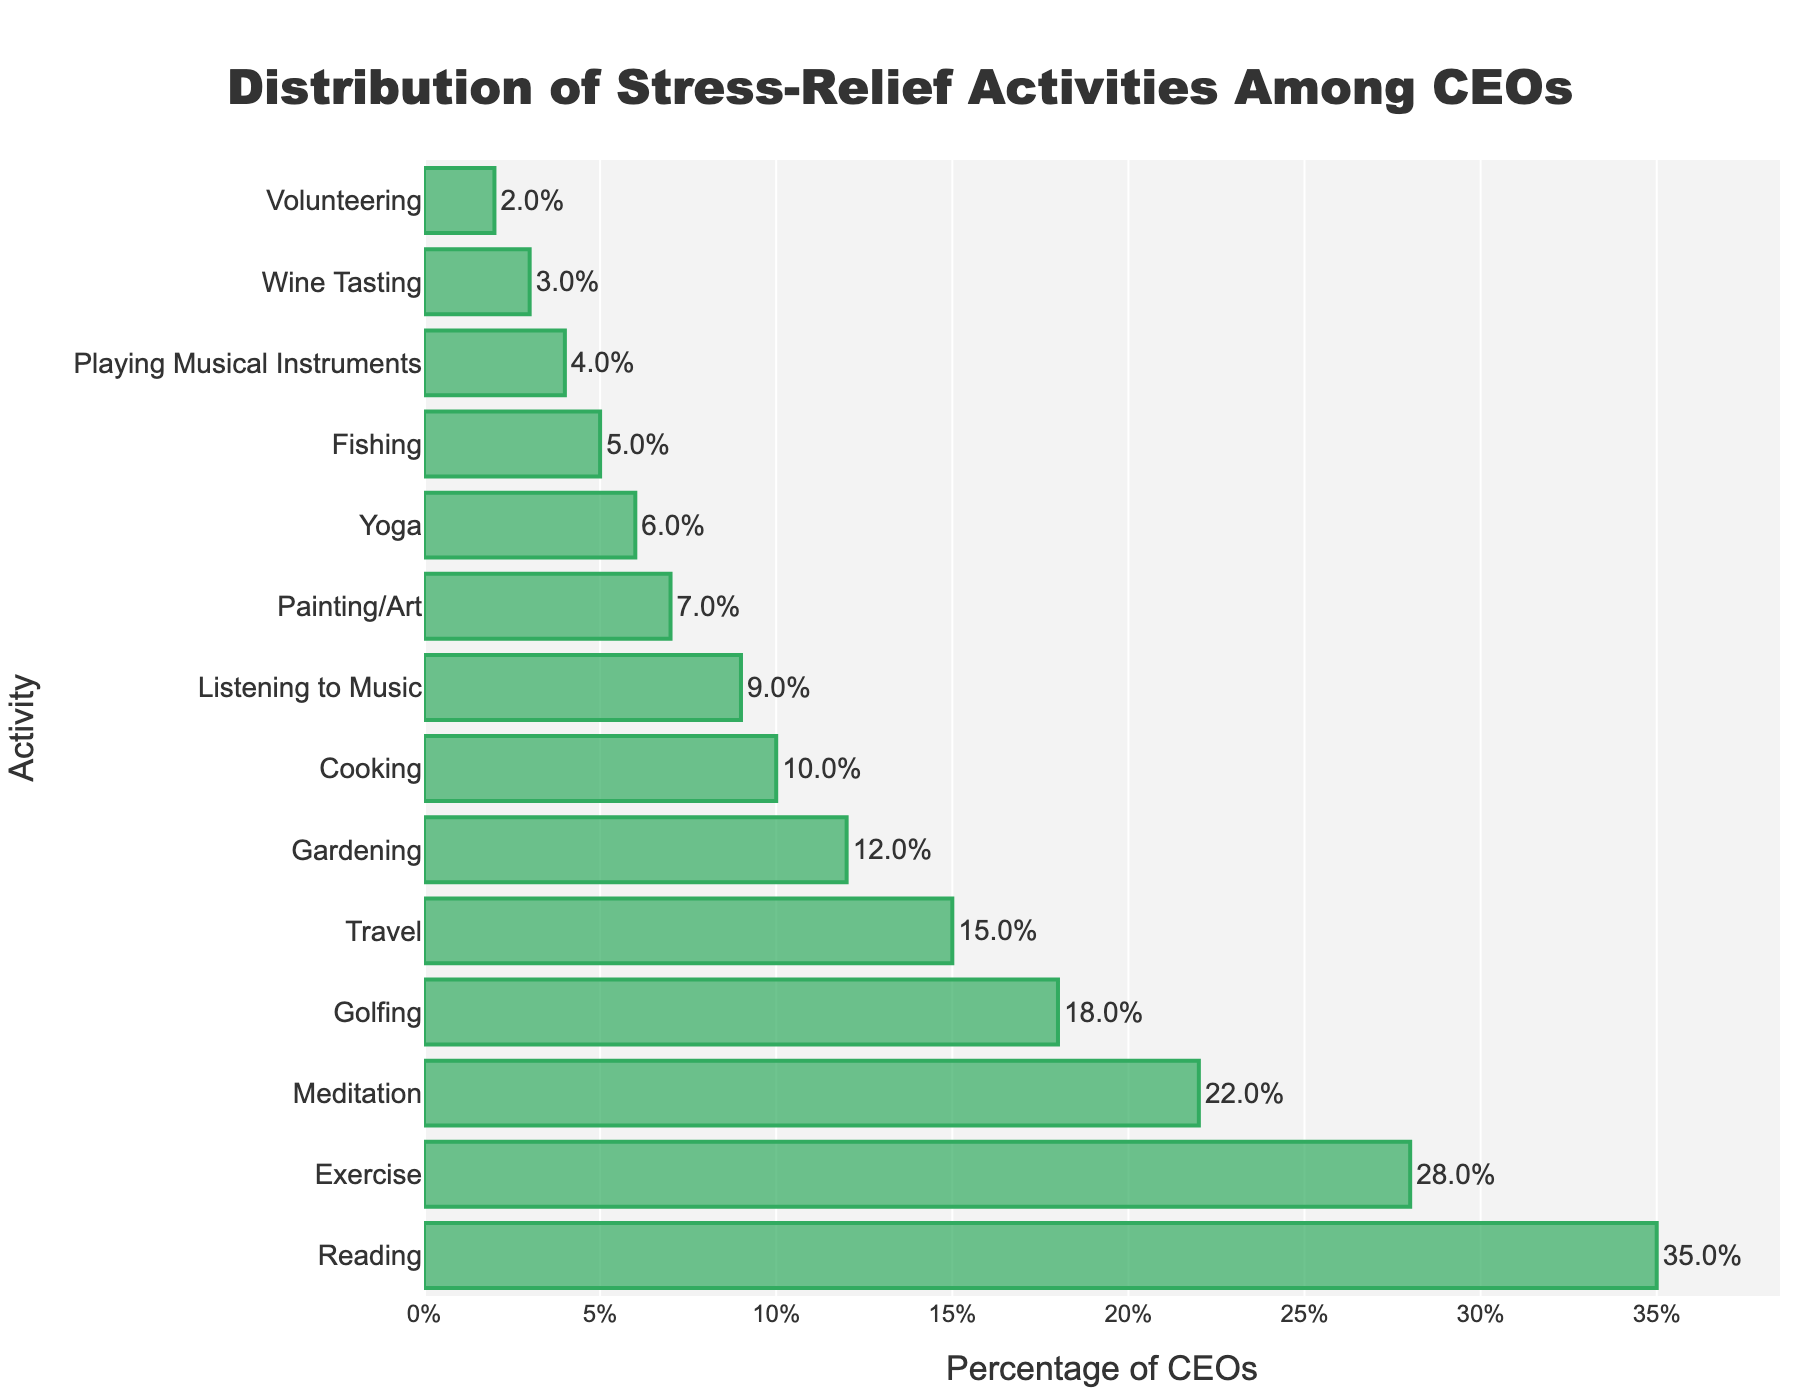Which stress-relief activity is the most popular among CEOs? The figure shows that the bar for "Reading" is the longest, indicating it has the highest percentage among the listed activities.
Answer: Reading How much more popular is exercise compared to gardening? From the figure, "Exercise" is at 28% and "Gardening" at 12%. Subtracting the percentage for gardening from exercise: 28% - 12% = 16%.
Answer: 16% What are the top three stress-relief activities among CEOs? The top three activities can be identified by looking at the three longest bars in the chart, which are "Reading" (35%), "Exercise" (28%), and "Meditation" (22%).
Answer: Reading, Exercise, Meditation Which stress-relief activity is just below golfing in popularity? By examining the chart, the activity listed immediately below "Golfing" (18%) is "Travel" at 15%.
Answer: Travel How many stress-relief activities have a percentage greater than 20%? By counting the bars with percentages greater than 20%, we find "Reading" (35%), "Exercise" (28%), and "Meditation" (22%), totaling to three activities.
Answer: 3 Is cooking more or less popular than listening to music? By comparing the lengths of the bars, "Cooking" (10%) is more popular than "Listening to Music" (9%).
Answer: More What is the total percentage of CEOs who engage in yoga and fishing? Summing up the percentages for "Yoga" (6%) and "Fishing" (5%) results in 6% + 5% = 11%.
Answer: 11% Which activity is the least popular among CEOs? The shortest bar in the chart corresponds to "Volunteering," which is at 2%.
Answer: Volunteering What’s the percentage difference between the most and least popular activities? The most popular activity, "Reading," is at 35%, and the least popular, "Volunteering," is at 2%. The difference is 35% - 2% = 33%.
Answer: 33% How many activities have a percentage lower than painting/art? "Painting/Art" is at 7%. The activities with lower percentages are "Yoga" (6%), "Fishing" (5%), "Playing Musical Instruments" (4%), "Wine Tasting" (3%), and "Volunteering" (2%), totalling to five activities.
Answer: 5 